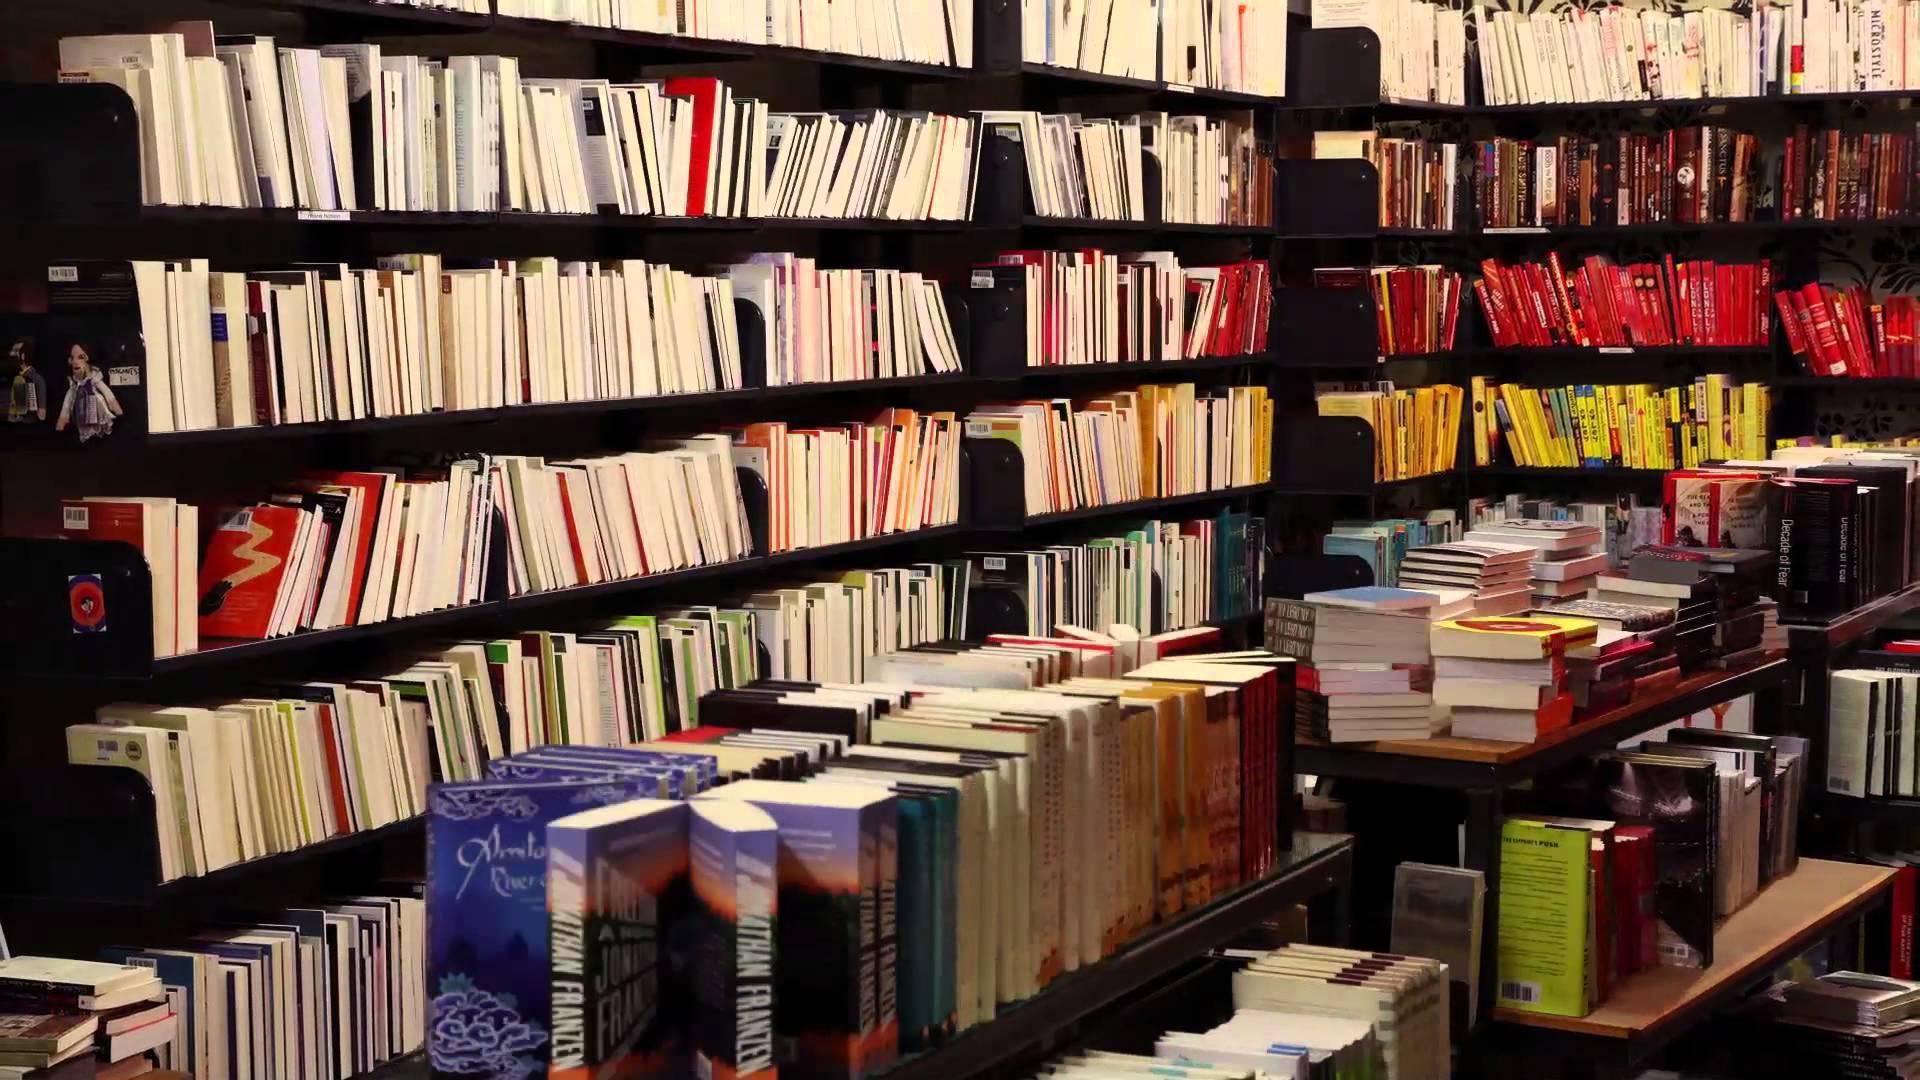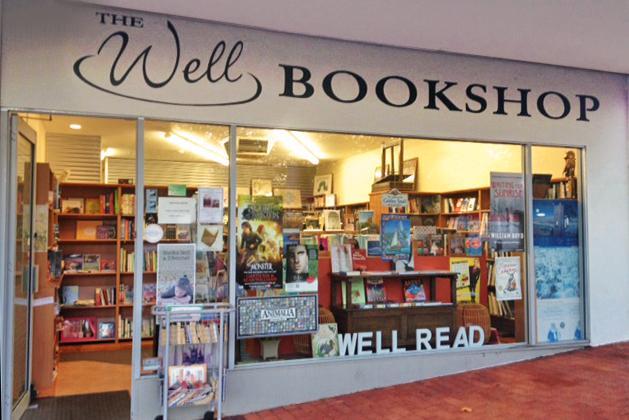The first image is the image on the left, the second image is the image on the right. For the images displayed, is the sentence "One image is the interior of a bookshop and one image is the exterior of a bookshop." factually correct? Answer yes or no. Yes. The first image is the image on the left, the second image is the image on the right. For the images shown, is this caption "The right image shows the exterior of a bookshop." true? Answer yes or no. Yes. 